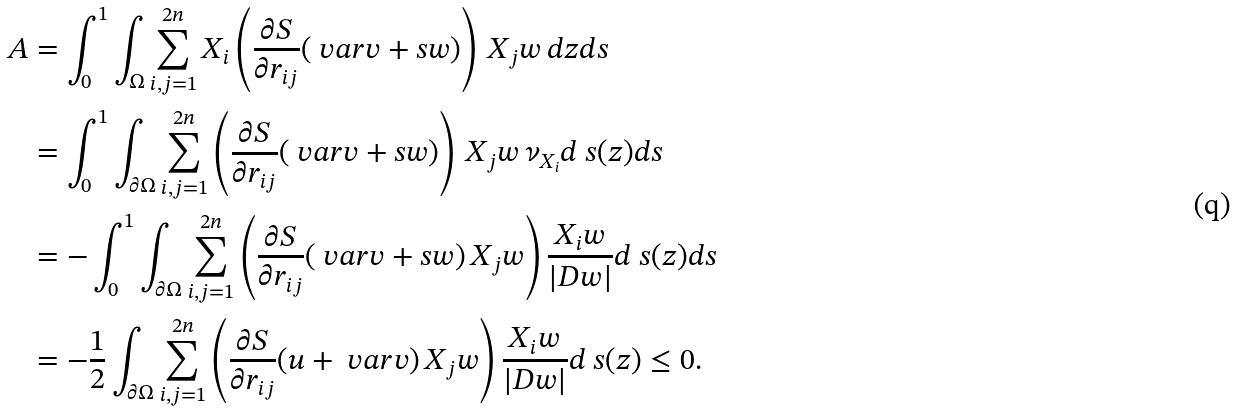<formula> <loc_0><loc_0><loc_500><loc_500>A & = \int _ { 0 } ^ { 1 } \int _ { \Omega } \sum _ { i , j = 1 } ^ { 2 n } X _ { i } \left ( \frac { \partial S } { \partial r _ { i j } } ( \ v a r v + s w ) \right ) \, X _ { j } w \, d z d s \\ & = \int _ { 0 } ^ { 1 } \int _ { \partial \Omega } \sum _ { i , j = 1 } ^ { 2 n } \left ( \frac { \partial S } { \partial r _ { i j } } ( \ v a r v + s w ) \right ) \, X _ { j } w \, \nu _ { X _ { i } } d \ s ( z ) d s \\ & = - \int _ { 0 } ^ { 1 } \int _ { \partial \Omega } \sum _ { i , j = 1 } ^ { 2 n } \left ( \frac { \partial S } { \partial r _ { i j } } ( \ v a r v + s w ) \, X _ { j } w \right ) \frac { { X _ { i } } w } { | D w | } d \ s ( z ) d s \\ & = - \frac { 1 } { 2 } \int _ { \partial \Omega } \sum _ { i , j = 1 } ^ { 2 n } \left ( \frac { \partial S } { \partial r _ { i j } } ( u + \ v a r v ) \, X _ { j } w \right ) \frac { { X _ { i } } w } { | D w | } d \ s ( z ) \leq 0 .</formula> 